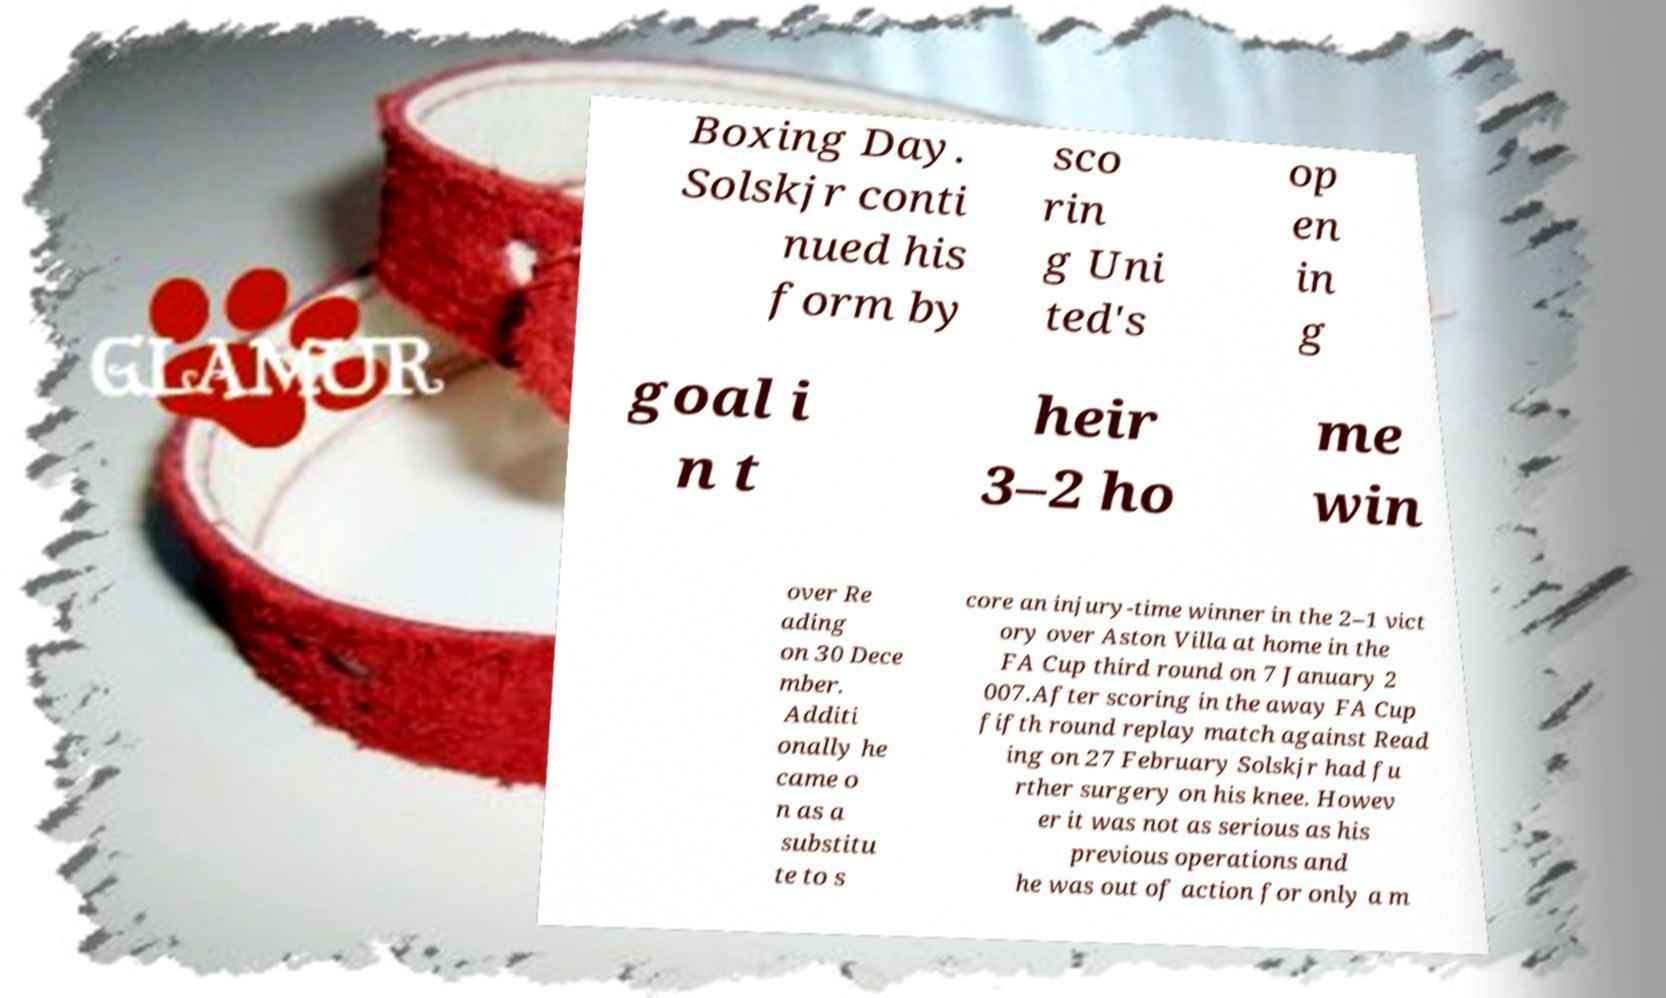For documentation purposes, I need the text within this image transcribed. Could you provide that? Boxing Day. Solskjr conti nued his form by sco rin g Uni ted's op en in g goal i n t heir 3–2 ho me win over Re ading on 30 Dece mber. Additi onally he came o n as a substitu te to s core an injury-time winner in the 2–1 vict ory over Aston Villa at home in the FA Cup third round on 7 January 2 007.After scoring in the away FA Cup fifth round replay match against Read ing on 27 February Solskjr had fu rther surgery on his knee. Howev er it was not as serious as his previous operations and he was out of action for only a m 